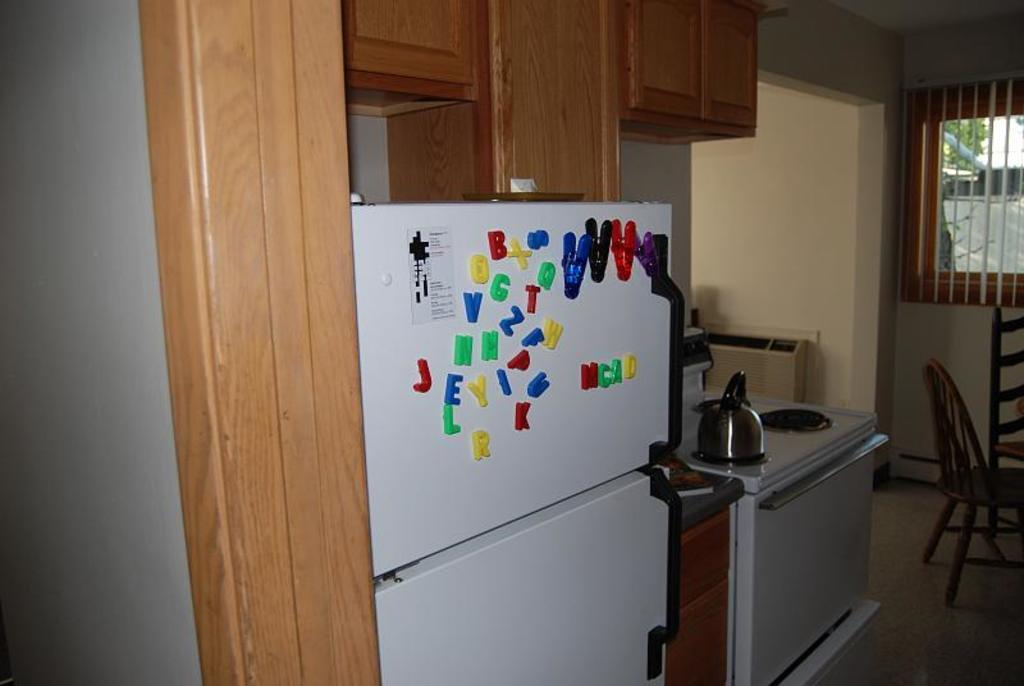<image>
Share a concise interpretation of the image provided. Refrigerator with letters on it and "MCAD" spelled together. 